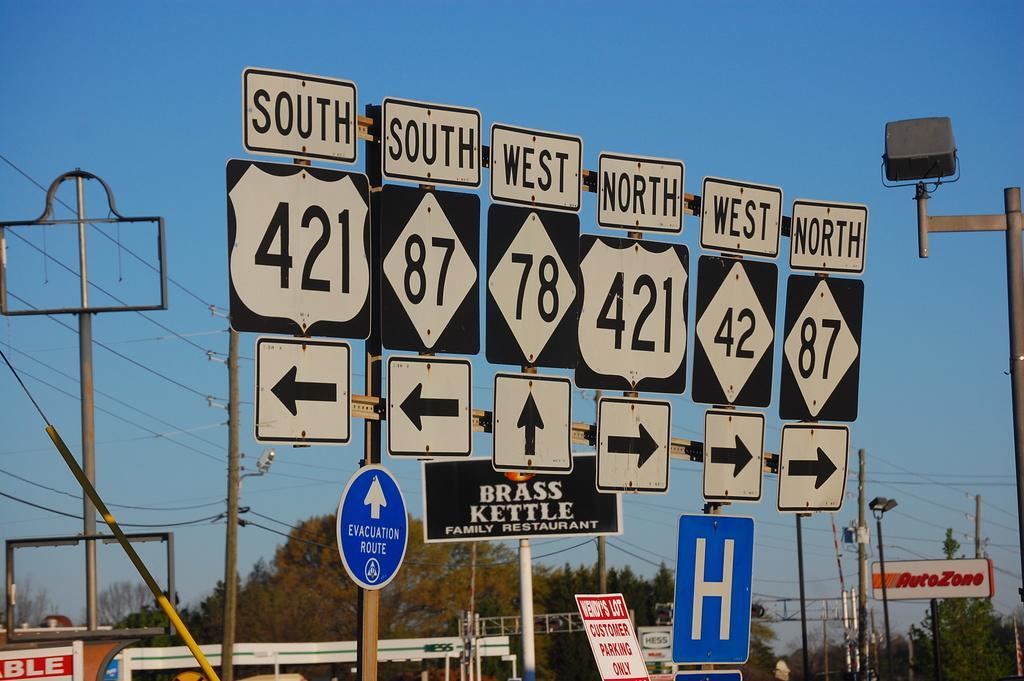<image>
Present a compact description of the photo's key features. Street signs with one which says the number 421 on it. 